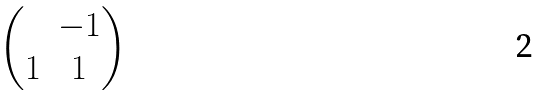<formula> <loc_0><loc_0><loc_500><loc_500>\begin{pmatrix} & - 1 \\ 1 & 1 \end{pmatrix}</formula> 